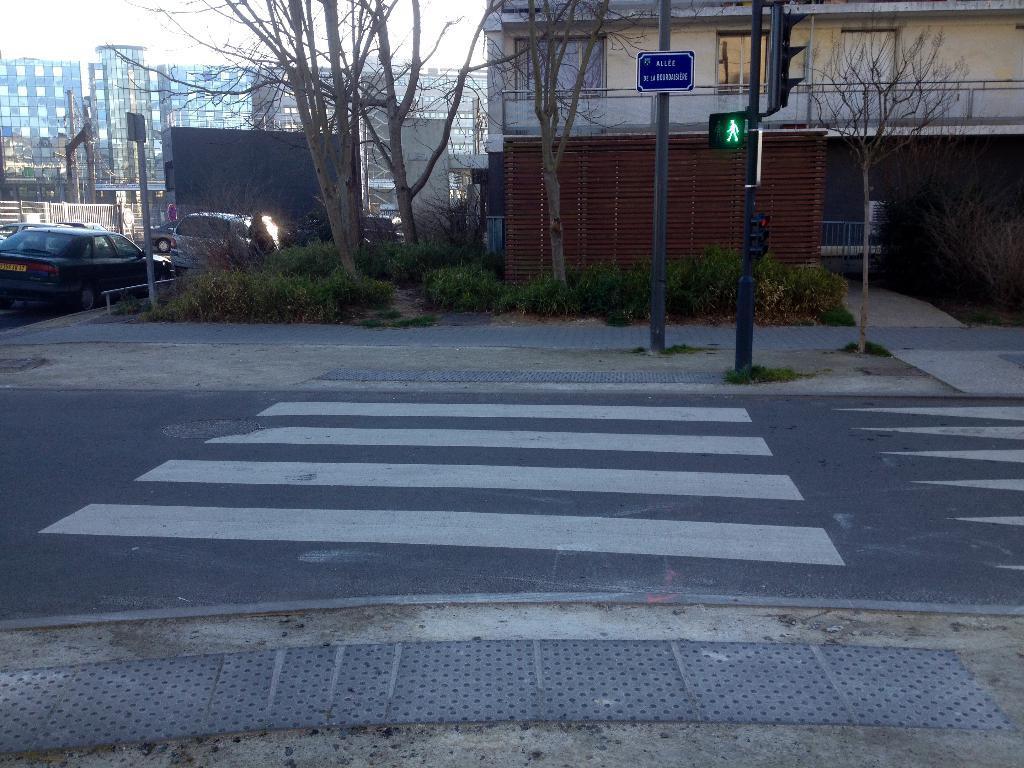Could you give a brief overview of what you see in this image? This picture shows buildings and trees and we see cars parked and grass on the ground and plants. We see few poles with signboard and a pole with the traffic signal light. 